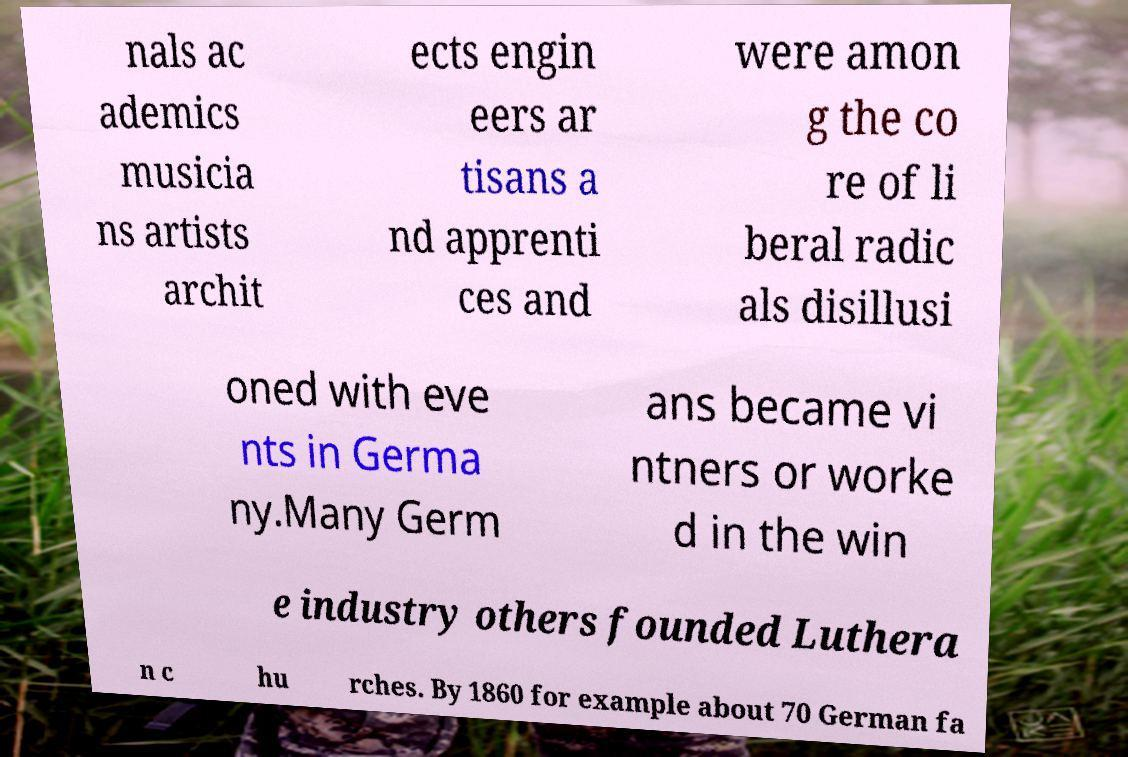I need the written content from this picture converted into text. Can you do that? nals ac ademics musicia ns artists archit ects engin eers ar tisans a nd apprenti ces and were amon g the co re of li beral radic als disillusi oned with eve nts in Germa ny.Many Germ ans became vi ntners or worke d in the win e industry others founded Luthera n c hu rches. By 1860 for example about 70 German fa 